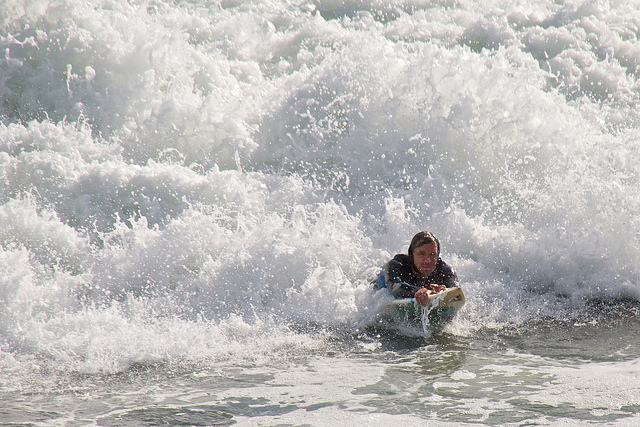How many black cars are there? The image actually depicts a person surfing in the waves, and no cars, black or otherwise, are visible. 